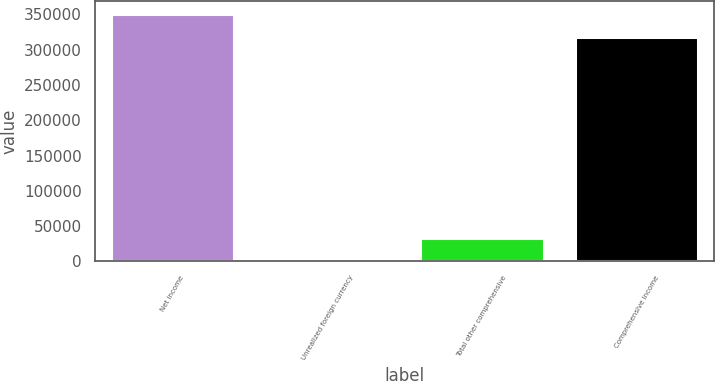<chart> <loc_0><loc_0><loc_500><loc_500><bar_chart><fcel>Net income<fcel>Unrealized foreign currency<fcel>Total other comprehensive<fcel>Comprehensive income<nl><fcel>351182<fcel>15<fcel>32927.7<fcel>318269<nl></chart> 